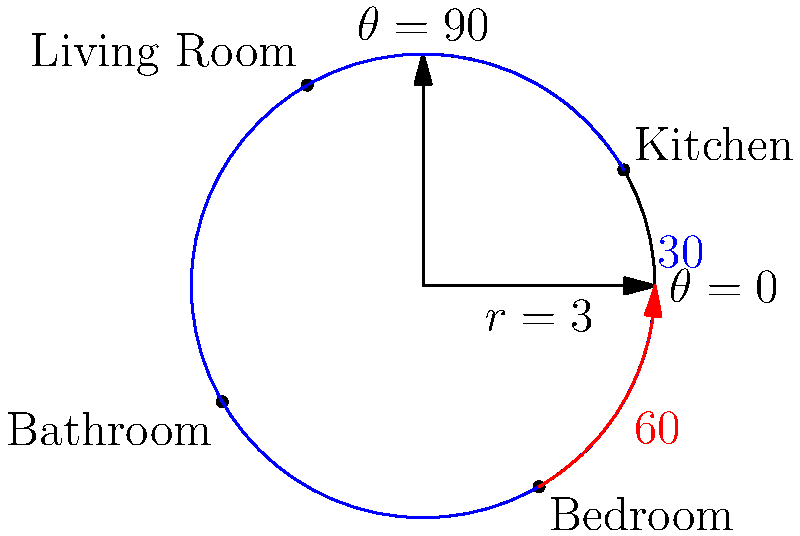In a patient's home, you've mapped out the main rooms using polar coordinates with the front door as the origin. The kitchen is located at $(3,30°)$, and the bedroom is at $(3,300°)$. What is the angular distance between the kitchen and the bedroom? To find the angular distance between the kitchen and the bedroom, we need to follow these steps:

1) Identify the angles for both rooms:
   Kitchen: $\theta_1 = 30°$
   Bedroom: $\theta_2 = 300°$

2) Calculate the absolute difference between these angles:
   $|\theta_2 - \theta_1| = |300° - 30°| = 270°$

3) However, in polar coordinates, the shortest angular distance is always $\leq 180°$. If the calculated difference is greater than $180°$, we need to subtract it from $360°$.

4) Since $270° > 180°$, we calculate:
   $360° - 270° = 90°$

5) Therefore, the shortest angular distance between the kitchen and the bedroom is $90°$.

This method ensures we're finding the shortest path around the circle, which is essential for efficient navigation in the patient's home.
Answer: $90°$ 